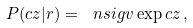<formula> <loc_0><loc_0><loc_500><loc_500>P ( c z | r ) = \ n s i g v \exp c z \, ,</formula> 